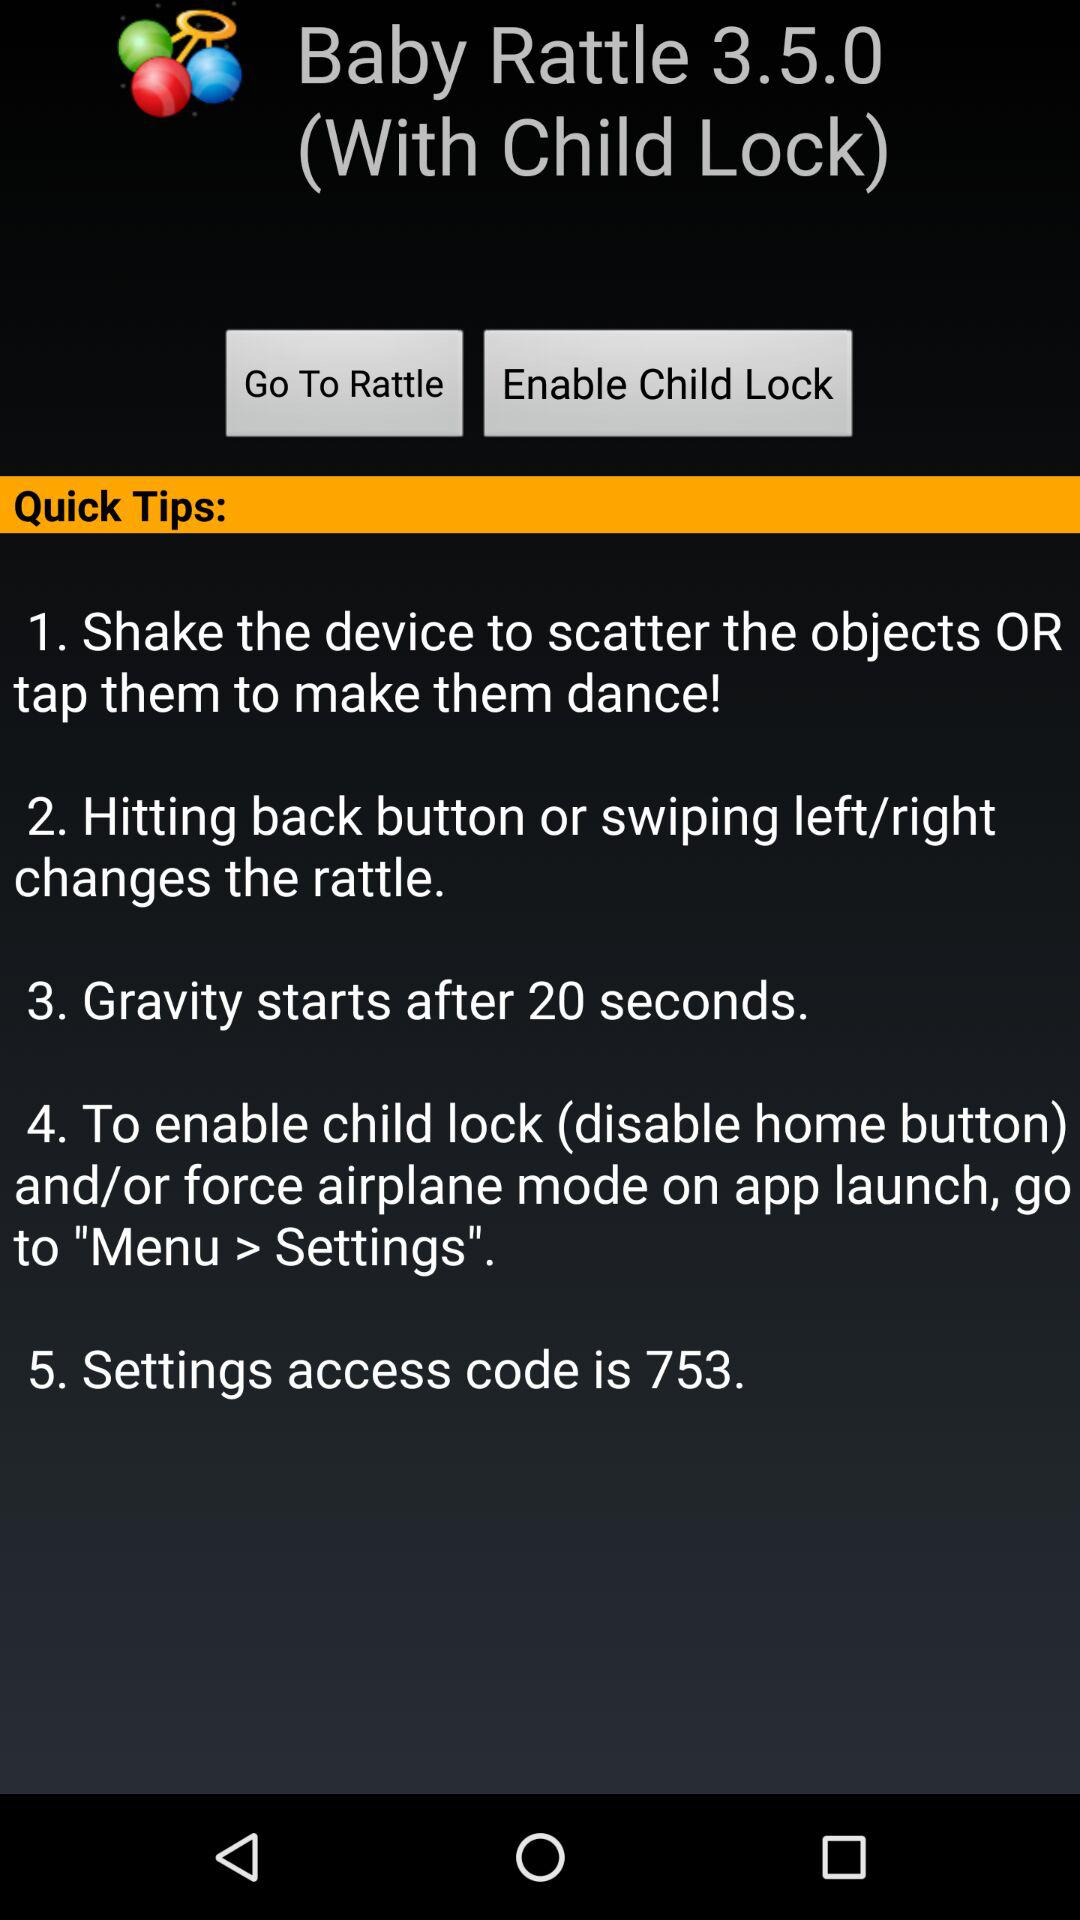What is the version of the app? The version of the app is 3.5.0. 